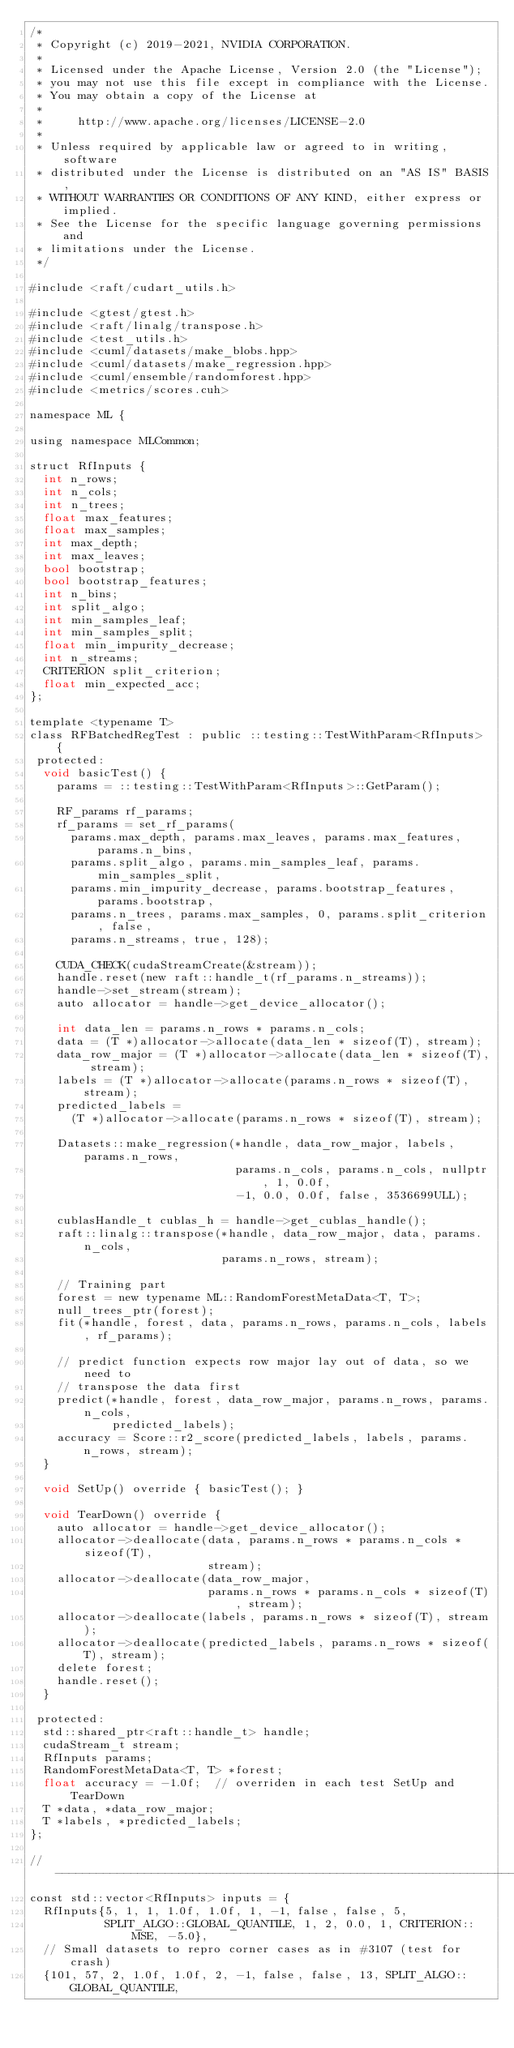Convert code to text. <code><loc_0><loc_0><loc_500><loc_500><_Cuda_>/*
 * Copyright (c) 2019-2021, NVIDIA CORPORATION.
 *
 * Licensed under the Apache License, Version 2.0 (the "License");
 * you may not use this file except in compliance with the License.
 * You may obtain a copy of the License at
 *
 *     http://www.apache.org/licenses/LICENSE-2.0
 *
 * Unless required by applicable law or agreed to in writing, software
 * distributed under the License is distributed on an "AS IS" BASIS,
 * WITHOUT WARRANTIES OR CONDITIONS OF ANY KIND, either express or implied.
 * See the License for the specific language governing permissions and
 * limitations under the License.
 */

#include <raft/cudart_utils.h>

#include <gtest/gtest.h>
#include <raft/linalg/transpose.h>
#include <test_utils.h>
#include <cuml/datasets/make_blobs.hpp>
#include <cuml/datasets/make_regression.hpp>
#include <cuml/ensemble/randomforest.hpp>
#include <metrics/scores.cuh>

namespace ML {

using namespace MLCommon;

struct RfInputs {
  int n_rows;
  int n_cols;
  int n_trees;
  float max_features;
  float max_samples;
  int max_depth;
  int max_leaves;
  bool bootstrap;
  bool bootstrap_features;
  int n_bins;
  int split_algo;
  int min_samples_leaf;
  int min_samples_split;
  float min_impurity_decrease;
  int n_streams;
  CRITERION split_criterion;
  float min_expected_acc;
};

template <typename T>
class RFBatchedRegTest : public ::testing::TestWithParam<RfInputs> {
 protected:
  void basicTest() {
    params = ::testing::TestWithParam<RfInputs>::GetParam();

    RF_params rf_params;
    rf_params = set_rf_params(
      params.max_depth, params.max_leaves, params.max_features, params.n_bins,
      params.split_algo, params.min_samples_leaf, params.min_samples_split,
      params.min_impurity_decrease, params.bootstrap_features, params.bootstrap,
      params.n_trees, params.max_samples, 0, params.split_criterion, false,
      params.n_streams, true, 128);

    CUDA_CHECK(cudaStreamCreate(&stream));
    handle.reset(new raft::handle_t(rf_params.n_streams));
    handle->set_stream(stream);
    auto allocator = handle->get_device_allocator();

    int data_len = params.n_rows * params.n_cols;
    data = (T *)allocator->allocate(data_len * sizeof(T), stream);
    data_row_major = (T *)allocator->allocate(data_len * sizeof(T), stream);
    labels = (T *)allocator->allocate(params.n_rows * sizeof(T), stream);
    predicted_labels =
      (T *)allocator->allocate(params.n_rows * sizeof(T), stream);

    Datasets::make_regression(*handle, data_row_major, labels, params.n_rows,
                              params.n_cols, params.n_cols, nullptr, 1, 0.0f,
                              -1, 0.0, 0.0f, false, 3536699ULL);

    cublasHandle_t cublas_h = handle->get_cublas_handle();
    raft::linalg::transpose(*handle, data_row_major, data, params.n_cols,
                            params.n_rows, stream);

    // Training part
    forest = new typename ML::RandomForestMetaData<T, T>;
    null_trees_ptr(forest);
    fit(*handle, forest, data, params.n_rows, params.n_cols, labels, rf_params);

    // predict function expects row major lay out of data, so we need to
    // transpose the data first
    predict(*handle, forest, data_row_major, params.n_rows, params.n_cols,
            predicted_labels);
    accuracy = Score::r2_score(predicted_labels, labels, params.n_rows, stream);
  }

  void SetUp() override { basicTest(); }

  void TearDown() override {
    auto allocator = handle->get_device_allocator();
    allocator->deallocate(data, params.n_rows * params.n_cols * sizeof(T),
                          stream);
    allocator->deallocate(data_row_major,
                          params.n_rows * params.n_cols * sizeof(T), stream);
    allocator->deallocate(labels, params.n_rows * sizeof(T), stream);
    allocator->deallocate(predicted_labels, params.n_rows * sizeof(T), stream);
    delete forest;
    handle.reset();
  }

 protected:
  std::shared_ptr<raft::handle_t> handle;
  cudaStream_t stream;
  RfInputs params;
  RandomForestMetaData<T, T> *forest;
  float accuracy = -1.0f;  // overriden in each test SetUp and TearDown
  T *data, *data_row_major;
  T *labels, *predicted_labels;
};

//-------------------------------------------------------------------------------------------------------------------------------------
const std::vector<RfInputs> inputs = {
  RfInputs{5, 1, 1, 1.0f, 1.0f, 1, -1, false, false, 5,
           SPLIT_ALGO::GLOBAL_QUANTILE, 1, 2, 0.0, 1, CRITERION::MSE, -5.0},
  // Small datasets to repro corner cases as in #3107 (test for crash)
  {101, 57, 2, 1.0f, 1.0f, 2, -1, false, false, 13, SPLIT_ALGO::GLOBAL_QUANTILE,</code> 